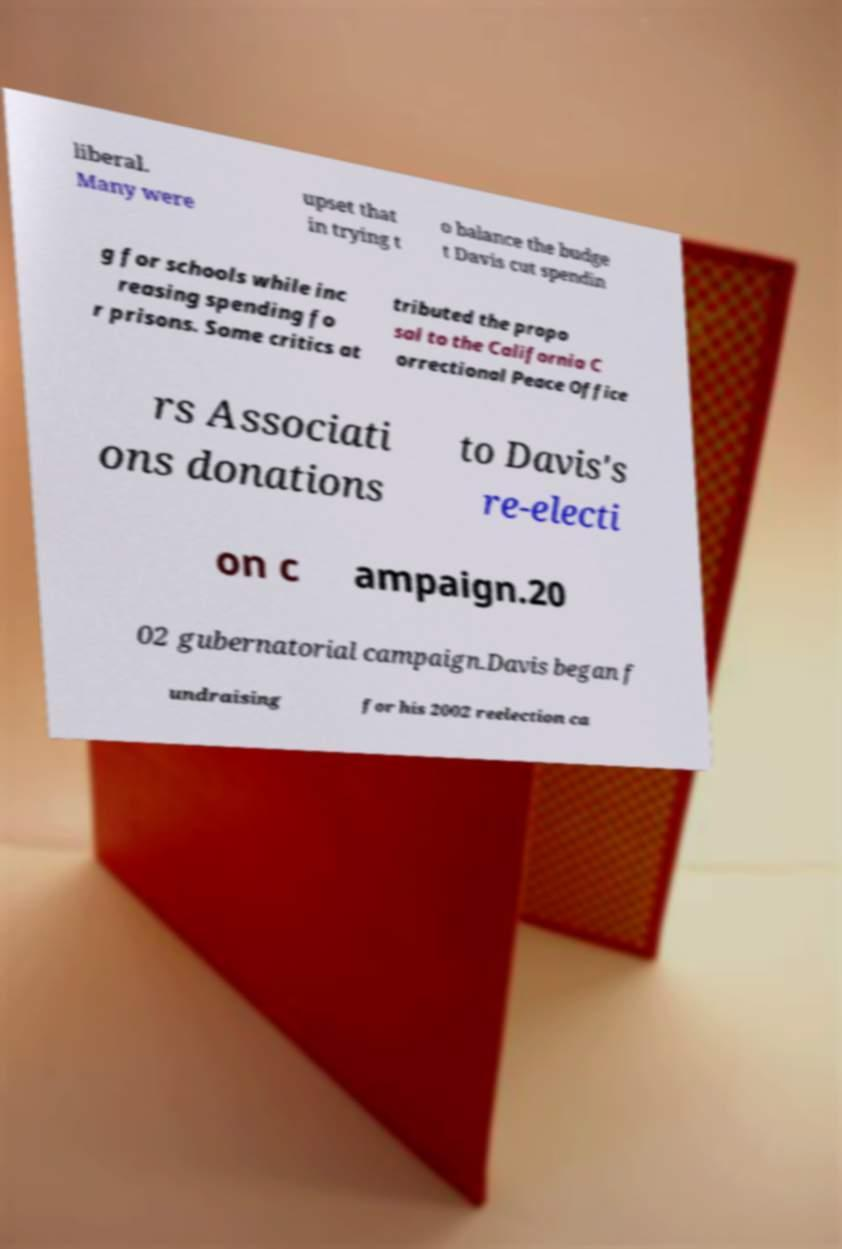Could you extract and type out the text from this image? liberal. Many were upset that in trying t o balance the budge t Davis cut spendin g for schools while inc reasing spending fo r prisons. Some critics at tributed the propo sal to the California C orrectional Peace Office rs Associati ons donations to Davis's re-electi on c ampaign.20 02 gubernatorial campaign.Davis began f undraising for his 2002 reelection ca 